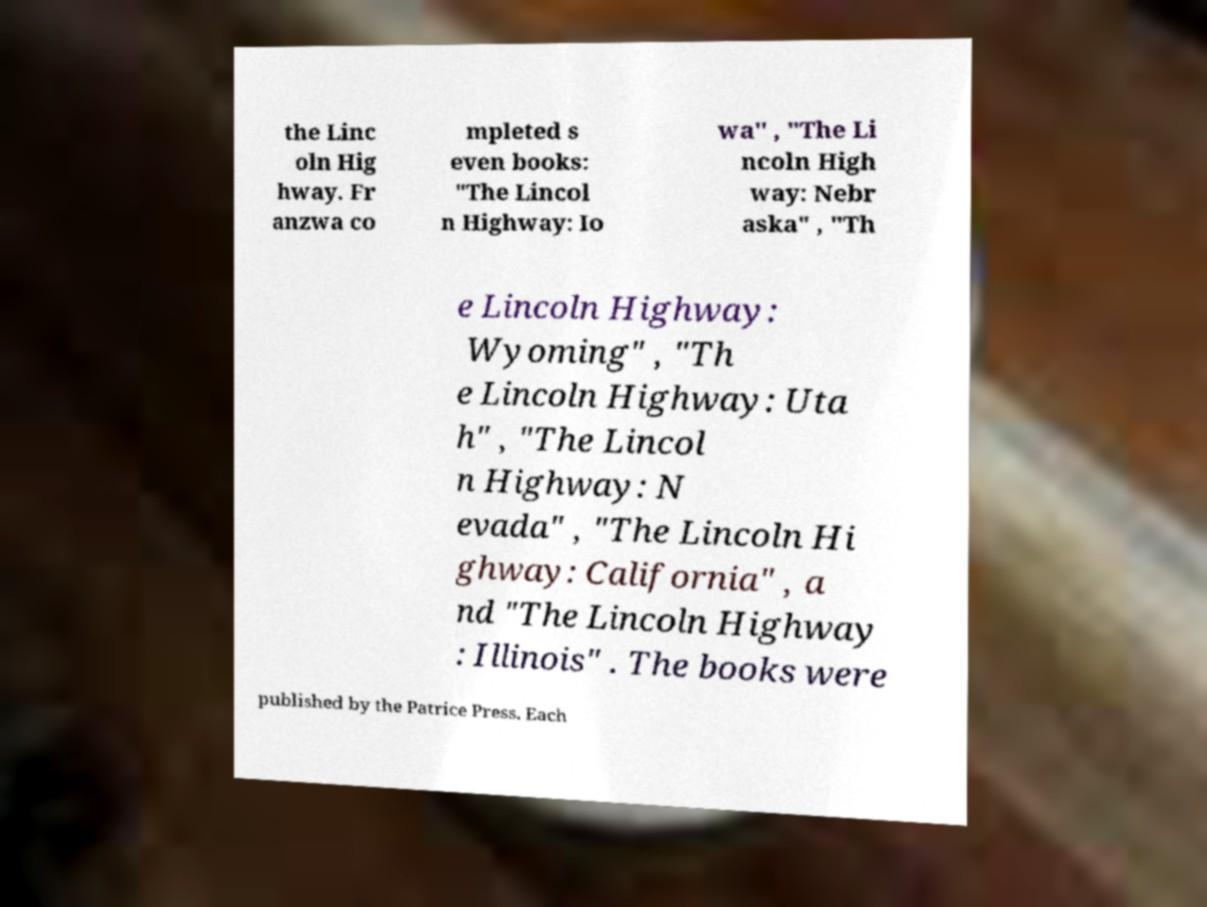Can you accurately transcribe the text from the provided image for me? the Linc oln Hig hway. Fr anzwa co mpleted s even books: "The Lincol n Highway: Io wa" , "The Li ncoln High way: Nebr aska" , "Th e Lincoln Highway: Wyoming" , "Th e Lincoln Highway: Uta h" , "The Lincol n Highway: N evada" , "The Lincoln Hi ghway: California" , a nd "The Lincoln Highway : Illinois" . The books were published by the Patrice Press. Each 